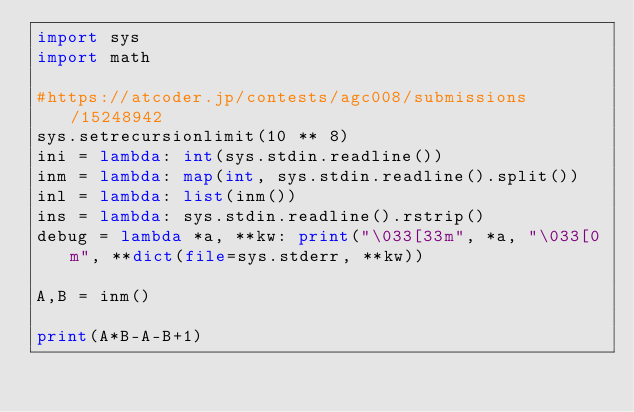Convert code to text. <code><loc_0><loc_0><loc_500><loc_500><_Python_>import sys
import math

#https://atcoder.jp/contests/agc008/submissions/15248942
sys.setrecursionlimit(10 ** 8)
ini = lambda: int(sys.stdin.readline())
inm = lambda: map(int, sys.stdin.readline().split())
inl = lambda: list(inm())
ins = lambda: sys.stdin.readline().rstrip()
debug = lambda *a, **kw: print("\033[33m", *a, "\033[0m", **dict(file=sys.stderr, **kw))

A,B = inm()

print(A*B-A-B+1)
</code> 